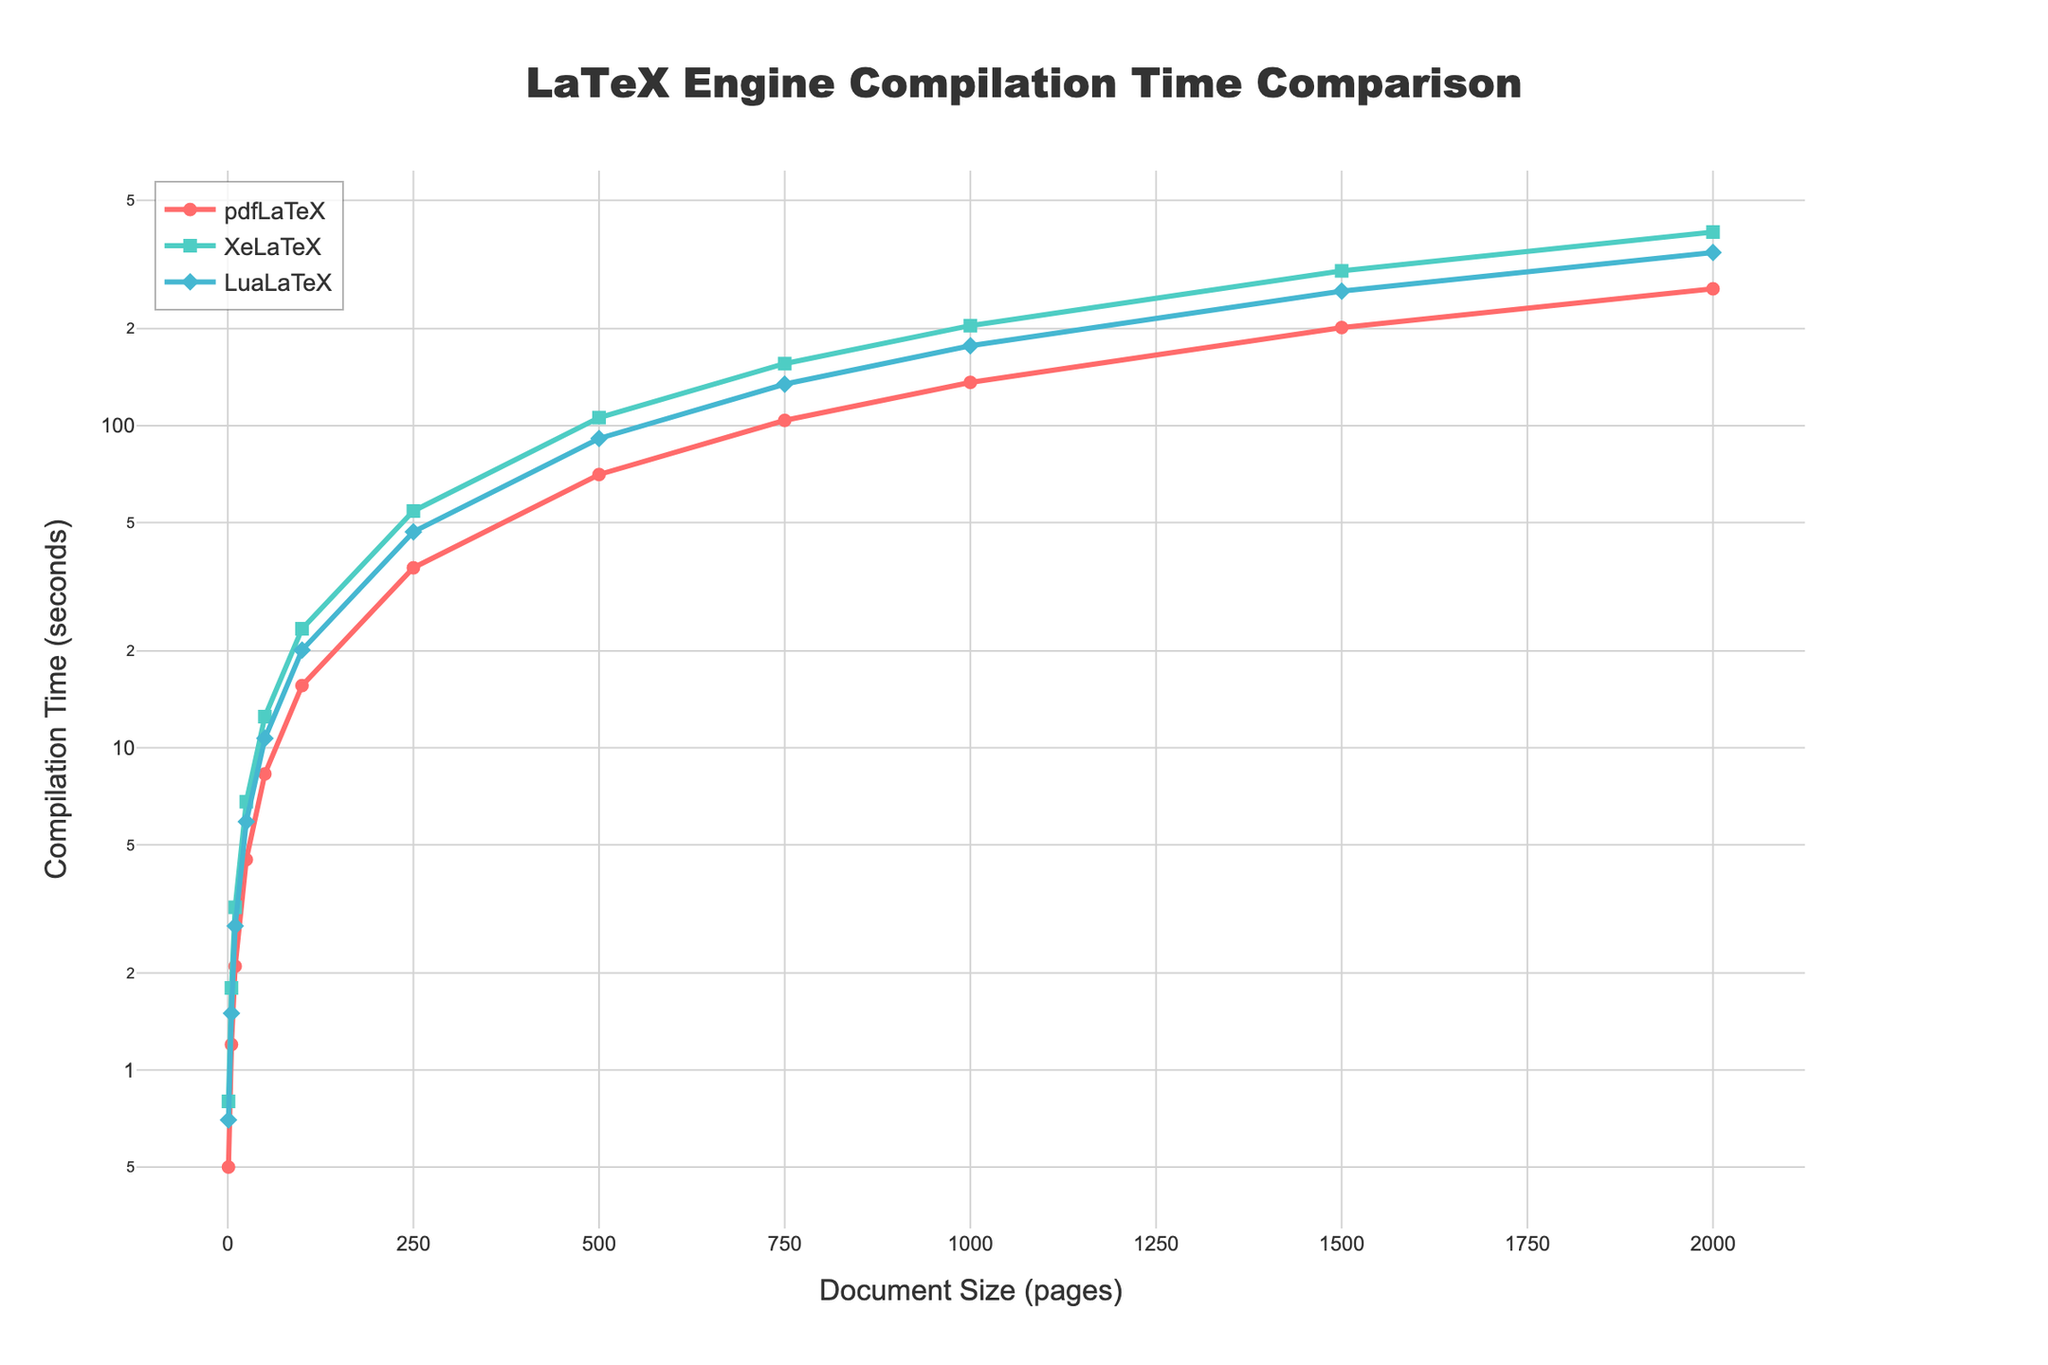What is the compilation time for XeLaTeX for a 1000-page document? Locate the 1000-page document size on the x-axis, then find the corresponding value for the XeLaTeX line. The line for XeLaTeX is represented by green squares, which shows the compilation time at this point.
Answer: 204.3 seconds Which LaTeX engine has the fastest compilation time for documents with 750 pages? Find the 750-page document size on the x-axis and observe the compilation times for all three LaTeX engines. The line represented by red circles (pdfLaTeX) is lowest on the y-axis compared to the green squares (XeLaTeX) and blue diamonds (LuaLaTeX) indicating it has the quickest compilation time.
Answer: pdfLaTeX How does the compilation time for pdfLaTeX change as the document size increases from 1 to 1000 pages? Observe the red circles representing pdfLaTeX along the x-axis values from 1 to 1000 pages. Initially low at 0.5 seconds for 1 page, the compilation time increases gradually to 136.2 seconds for 1000 pages, indicating a consistent upward trend.
Answer: It increases What is the difference in compilation time between XeLaTeX and LuaLaTeX for a 2000-page document? Locate the 2000-page point on the x-axis, then find the corresponding values for XeLaTeX and LuaLaTeX. XeLaTeX shows 398.7 seconds, and LuaLaTeX shows 344.6 seconds. Subtract the LuaLaTeX value from the XeLaTeX value: 398.7 - 344.6 = 54.1 seconds.
Answer: 54.1 seconds Does LuaLaTeX show a logarithmic trend in compilation time as document size increases? Check the pattern of the blue diamond markers representing LuaLaTeX. As document size (x-axis) increases logarithmically, the LuaLaTeX compilation time (y-axis) also increases consistently on a log scale y-axis, which indicates a logarithmic trend.
Answer: Yes For document sizes above 500 pages, which LaTeX engine demonstrates the steepest rate of increase in compilation time? Focus on the lines beyond 500 pages along the x-axis. The green squares (XeLaTeX) rise more steeply compared to the red circles (pdfLaTeX) and blue diamonds (LuaLaTeX), indicating the highest rate of increase.
Answer: XeLaTeX Between LuaLaTeX and pdfLaTeX, which engine is consistently faster for smaller documents (1, 5, and 10 pages)? Locate the data points for 1, 5, and 10 pages on the x-axis, then compare the red circles (pdfLaTeX) and blue diamonds (LuaLaTeX). For 1 page: pdfLaTeX (0.5) < LuaLaTeX (0.7); for 5 pages: pdfLaTeX (1.2) < LuaLaTeX (1.5); for 10 pages: pdfLaTeX (2.1) < LuaLaTeX (2.8).
Answer: pdfLaTeX 